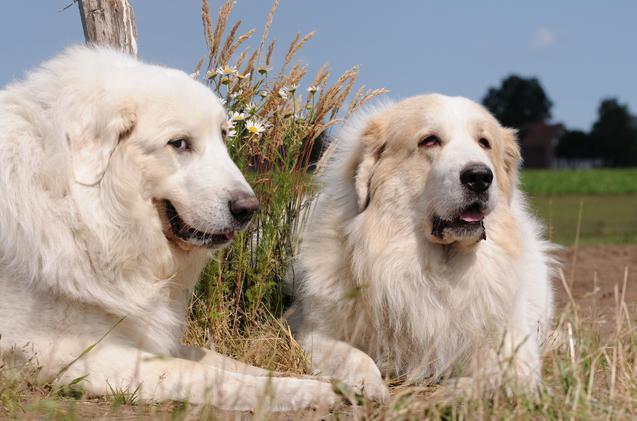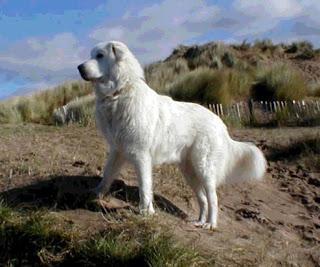The first image is the image on the left, the second image is the image on the right. Assess this claim about the two images: "Exactly three large white dogs are shown in outdoor settings.". Correct or not? Answer yes or no. Yes. The first image is the image on the left, the second image is the image on the right. Evaluate the accuracy of this statement regarding the images: "There are a total of three dogs, and there are more dogs in the left image.". Is it true? Answer yes or no. Yes. 